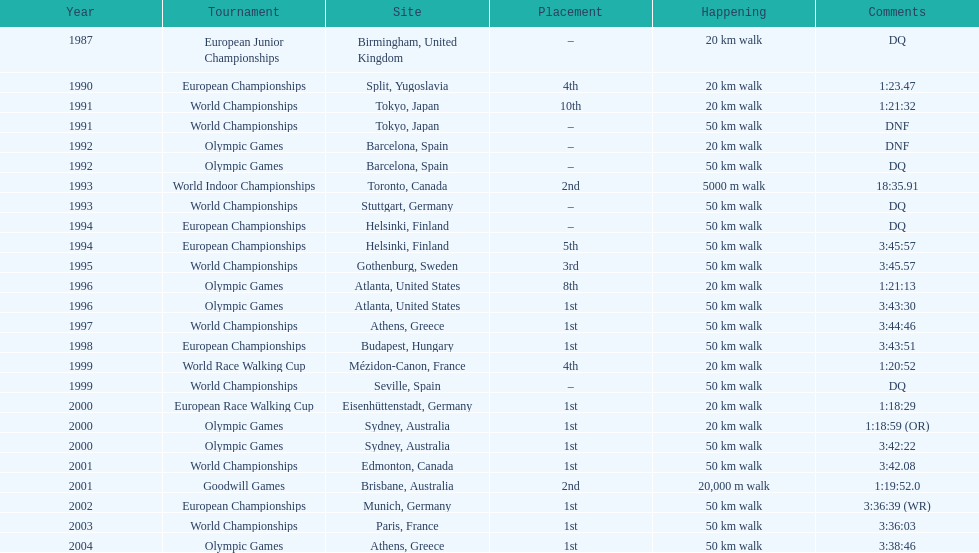How many times was korzeniowski disqualified from a competition? 5. 